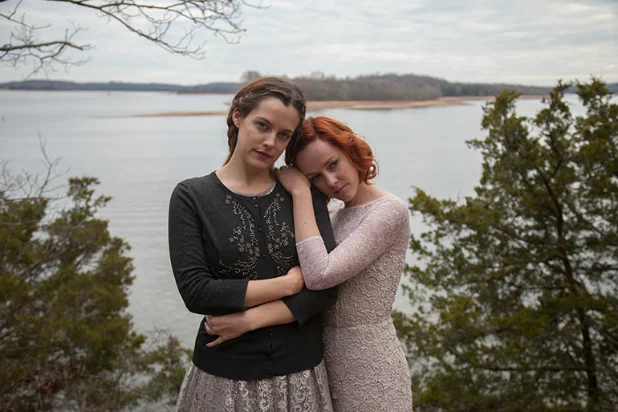What might the choice of clothing suggest about the subjects' characters or the setting of the image? The choice of clothing, with the woman in black adorned in a floral pattern and the other in a textured pink dress, suggests a blend of elegance and simplicity. These outfits could indicate the time during cooler seasons, as suggested by their long sleeves and layered attire. Additionally, the classical style of their clothing might hint at a setting away from urban distractions, aligning with the tranquil and untouched natural environment. This choice might also underscore their personal styles or represent their emotional bond, highlighted by soft colors and comforting fabrics that evoke warmth and closeness. 